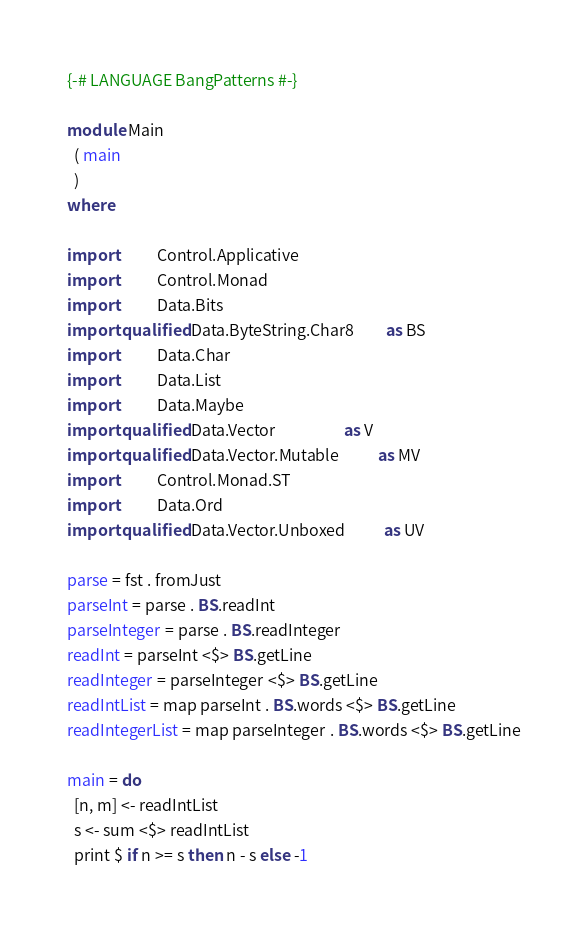Convert code to text. <code><loc_0><loc_0><loc_500><loc_500><_Haskell_>{-# LANGUAGE BangPatterns #-}

module Main
  ( main
  )
where

import           Control.Applicative
import           Control.Monad
import           Data.Bits
import qualified Data.ByteString.Char8         as BS
import           Data.Char
import           Data.List
import           Data.Maybe
import qualified Data.Vector                   as V
import qualified Data.Vector.Mutable           as MV
import           Control.Monad.ST
import           Data.Ord
import qualified Data.Vector.Unboxed           as UV

parse = fst . fromJust
parseInt = parse . BS.readInt
parseInteger = parse . BS.readInteger
readInt = parseInt <$> BS.getLine
readInteger = parseInteger <$> BS.getLine
readIntList = map parseInt . BS.words <$> BS.getLine
readIntegerList = map parseInteger . BS.words <$> BS.getLine

main = do
  [n, m] <- readIntList
  s <- sum <$> readIntList
  print $ if n >= s then n - s else -1
</code> 